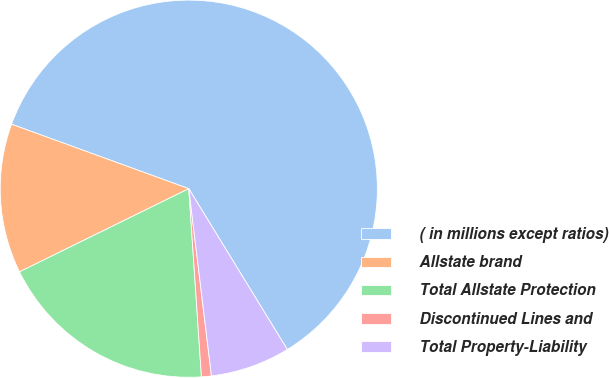Convert chart to OTSL. <chart><loc_0><loc_0><loc_500><loc_500><pie_chart><fcel>( in millions except ratios)<fcel>Allstate brand<fcel>Total Allstate Protection<fcel>Discontinued Lines and<fcel>Total Property-Liability<nl><fcel>60.7%<fcel>12.82%<fcel>18.8%<fcel>0.85%<fcel>6.83%<nl></chart> 